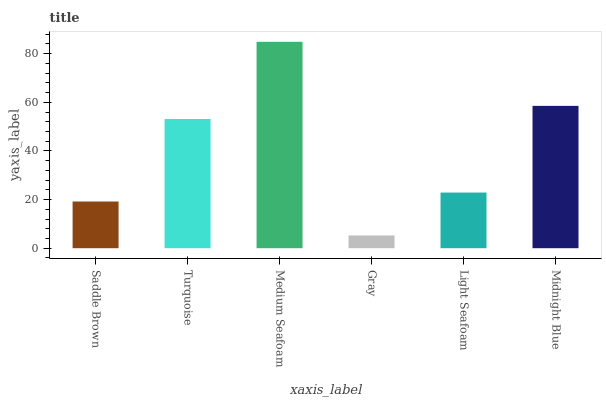Is Gray the minimum?
Answer yes or no. Yes. Is Medium Seafoam the maximum?
Answer yes or no. Yes. Is Turquoise the minimum?
Answer yes or no. No. Is Turquoise the maximum?
Answer yes or no. No. Is Turquoise greater than Saddle Brown?
Answer yes or no. Yes. Is Saddle Brown less than Turquoise?
Answer yes or no. Yes. Is Saddle Brown greater than Turquoise?
Answer yes or no. No. Is Turquoise less than Saddle Brown?
Answer yes or no. No. Is Turquoise the high median?
Answer yes or no. Yes. Is Light Seafoam the low median?
Answer yes or no. Yes. Is Saddle Brown the high median?
Answer yes or no. No. Is Medium Seafoam the low median?
Answer yes or no. No. 